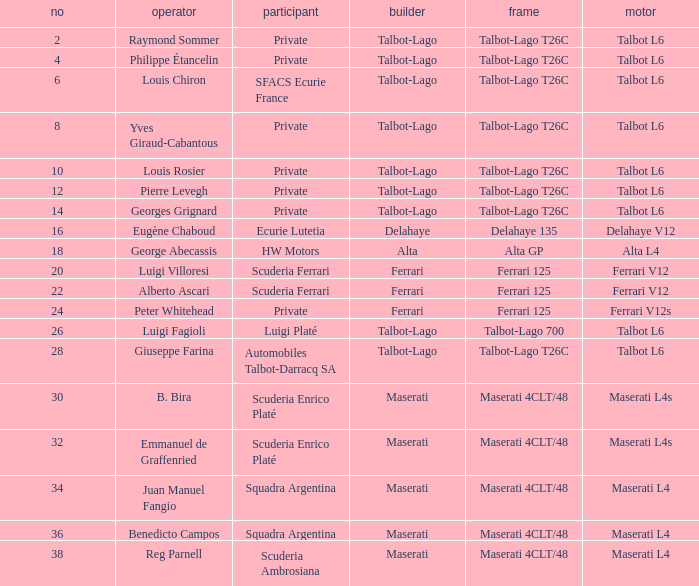Write the full table. {'header': ['no', 'operator', 'participant', 'builder', 'frame', 'motor'], 'rows': [['2', 'Raymond Sommer', 'Private', 'Talbot-Lago', 'Talbot-Lago T26C', 'Talbot L6'], ['4', 'Philippe Étancelin', 'Private', 'Talbot-Lago', 'Talbot-Lago T26C', 'Talbot L6'], ['6', 'Louis Chiron', 'SFACS Ecurie France', 'Talbot-Lago', 'Talbot-Lago T26C', 'Talbot L6'], ['8', 'Yves Giraud-Cabantous', 'Private', 'Talbot-Lago', 'Talbot-Lago T26C', 'Talbot L6'], ['10', 'Louis Rosier', 'Private', 'Talbot-Lago', 'Talbot-Lago T26C', 'Talbot L6'], ['12', 'Pierre Levegh', 'Private', 'Talbot-Lago', 'Talbot-Lago T26C', 'Talbot L6'], ['14', 'Georges Grignard', 'Private', 'Talbot-Lago', 'Talbot-Lago T26C', 'Talbot L6'], ['16', 'Eugène Chaboud', 'Ecurie Lutetia', 'Delahaye', 'Delahaye 135', 'Delahaye V12'], ['18', 'George Abecassis', 'HW Motors', 'Alta', 'Alta GP', 'Alta L4'], ['20', 'Luigi Villoresi', 'Scuderia Ferrari', 'Ferrari', 'Ferrari 125', 'Ferrari V12'], ['22', 'Alberto Ascari', 'Scuderia Ferrari', 'Ferrari', 'Ferrari 125', 'Ferrari V12'], ['24', 'Peter Whitehead', 'Private', 'Ferrari', 'Ferrari 125', 'Ferrari V12s'], ['26', 'Luigi Fagioli', 'Luigi Platé', 'Talbot-Lago', 'Talbot-Lago 700', 'Talbot L6'], ['28', 'Giuseppe Farina', 'Automobiles Talbot-Darracq SA', 'Talbot-Lago', 'Talbot-Lago T26C', 'Talbot L6'], ['30', 'B. Bira', 'Scuderia Enrico Platé', 'Maserati', 'Maserati 4CLT/48', 'Maserati L4s'], ['32', 'Emmanuel de Graffenried', 'Scuderia Enrico Platé', 'Maserati', 'Maserati 4CLT/48', 'Maserati L4s'], ['34', 'Juan Manuel Fangio', 'Squadra Argentina', 'Maserati', 'Maserati 4CLT/48', 'Maserati L4'], ['36', 'Benedicto Campos', 'Squadra Argentina', 'Maserati', 'Maserati 4CLT/48', 'Maserati L4'], ['38', 'Reg Parnell', 'Scuderia Ambrosiana', 'Maserati', 'Maserati 4CLT/48', 'Maserati L4']]} Name the chassis for sfacs ecurie france Talbot-Lago T26C. 